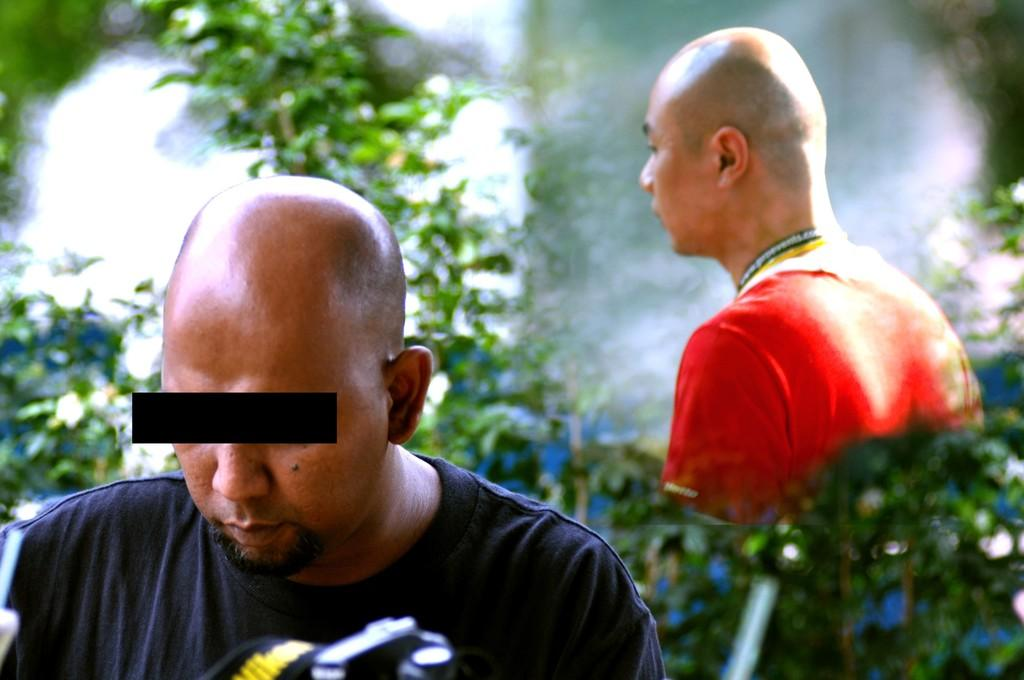How many people are present in the image? There are two people in the image. What can be seen in the background of the image? There are plants in the background of the image. What time of day is it in the image, and what is the agreement between the two people? The time of day and any agreement between the two people cannot be determined from the image, as there is no information provided about the time or any agreement. 